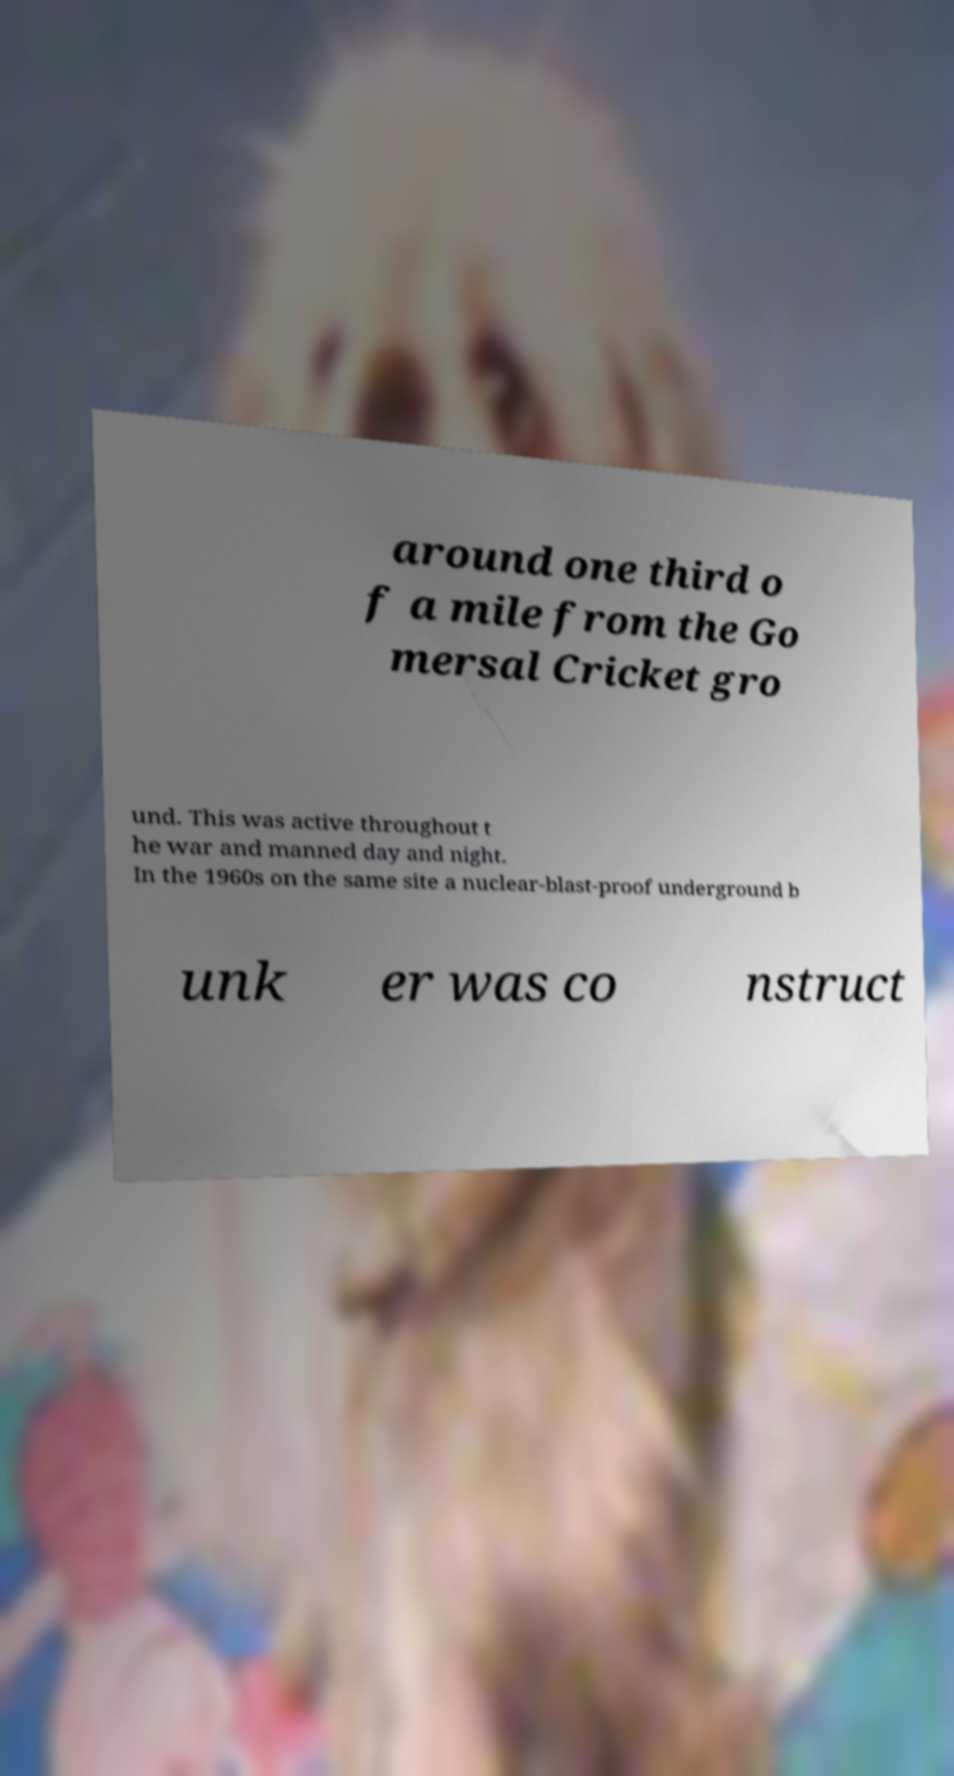I need the written content from this picture converted into text. Can you do that? around one third o f a mile from the Go mersal Cricket gro und. This was active throughout t he war and manned day and night. In the 1960s on the same site a nuclear-blast-proof underground b unk er was co nstruct 